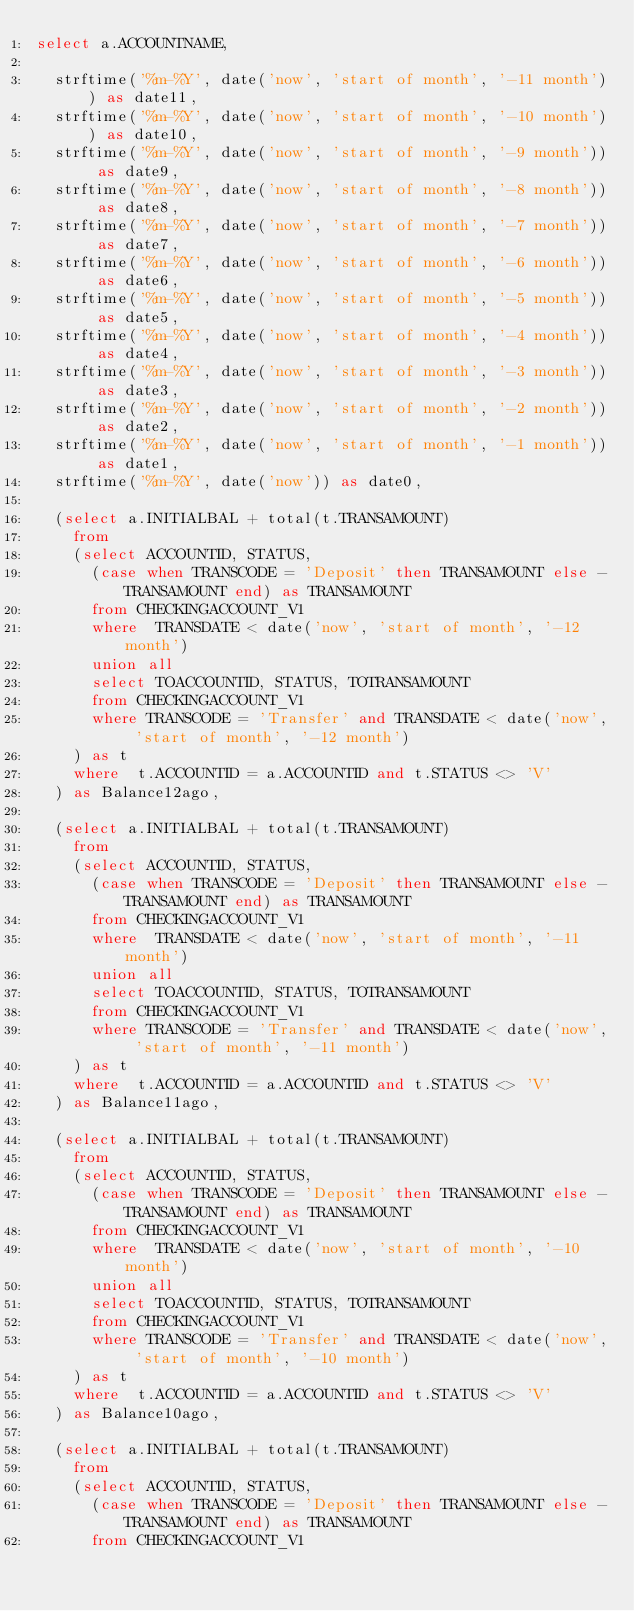Convert code to text. <code><loc_0><loc_0><loc_500><loc_500><_SQL_>select a.ACCOUNTNAME,

	strftime('%m-%Y', date('now', 'start of month', '-11 month')) as date11,
	strftime('%m-%Y', date('now', 'start of month', '-10 month')) as date10,
	strftime('%m-%Y', date('now', 'start of month', '-9 month')) as date9,
	strftime('%m-%Y', date('now', 'start of month', '-8 month')) as date8,
	strftime('%m-%Y', date('now', 'start of month', '-7 month')) as date7,
	strftime('%m-%Y', date('now', 'start of month', '-6 month')) as date6,
	strftime('%m-%Y', date('now', 'start of month', '-5 month')) as date5,
	strftime('%m-%Y', date('now', 'start of month', '-4 month')) as date4,
	strftime('%m-%Y', date('now', 'start of month', '-3 month')) as date3,
	strftime('%m-%Y', date('now', 'start of month', '-2 month')) as date2,
	strftime('%m-%Y', date('now', 'start of month', '-1 month')) as date1,
	strftime('%m-%Y', date('now')) as date0,

	(select a.INITIALBAL + total(t.TRANSAMOUNT)
		from
		(select ACCOUNTID, STATUS,
			(case when TRANSCODE = 'Deposit' then TRANSAMOUNT else -TRANSAMOUNT end) as TRANSAMOUNT
			from CHECKINGACCOUNT_V1
			where  TRANSDATE < date('now', 'start of month', '-12 month')
			union all
			select TOACCOUNTID, STATUS, TOTRANSAMOUNT 
			from CHECKINGACCOUNT_V1
			where TRANSCODE = 'Transfer' and TRANSDATE < date('now', 'start of month', '-12 month')
		) as t
		where  t.ACCOUNTID = a.ACCOUNTID and t.STATUS <> 'V'
	) as Balance12ago,

	(select a.INITIALBAL + total(t.TRANSAMOUNT)
		from
		(select ACCOUNTID, STATUS,
			(case when TRANSCODE = 'Deposit' then TRANSAMOUNT else -TRANSAMOUNT end) as TRANSAMOUNT
			from CHECKINGACCOUNT_V1
			where  TRANSDATE < date('now', 'start of month', '-11 month')
			union all
			select TOACCOUNTID, STATUS, TOTRANSAMOUNT 
			from CHECKINGACCOUNT_V1
			where TRANSCODE = 'Transfer' and TRANSDATE < date('now', 'start of month', '-11 month')
		) as t
		where  t.ACCOUNTID = a.ACCOUNTID and t.STATUS <> 'V'
	) as Balance11ago,

	(select a.INITIALBAL + total(t.TRANSAMOUNT)
		from
		(select ACCOUNTID, STATUS,
			(case when TRANSCODE = 'Deposit' then TRANSAMOUNT else -TRANSAMOUNT end) as TRANSAMOUNT
			from CHECKINGACCOUNT_V1
			where  TRANSDATE < date('now', 'start of month', '-10 month')
			union all
			select TOACCOUNTID, STATUS, TOTRANSAMOUNT 
			from CHECKINGACCOUNT_V1
			where TRANSCODE = 'Transfer' and TRANSDATE < date('now', 'start of month', '-10 month')
		) as t
		where  t.ACCOUNTID = a.ACCOUNTID and t.STATUS <> 'V'
	) as Balance10ago,

	(select a.INITIALBAL + total(t.TRANSAMOUNT)
		from
		(select ACCOUNTID, STATUS,
			(case when TRANSCODE = 'Deposit' then TRANSAMOUNT else -TRANSAMOUNT end) as TRANSAMOUNT
			from CHECKINGACCOUNT_V1</code> 